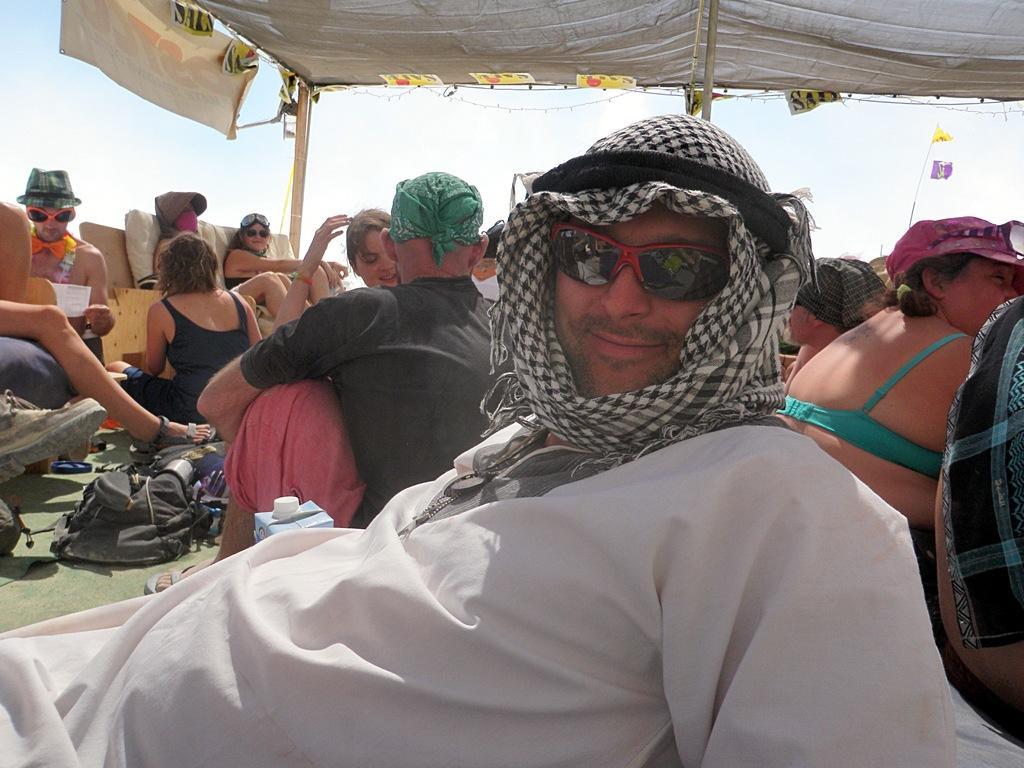In one or two sentences, can you explain what this image depicts? In this image I can see there are group of persons visible under the tent ,at the top there is the sky. 